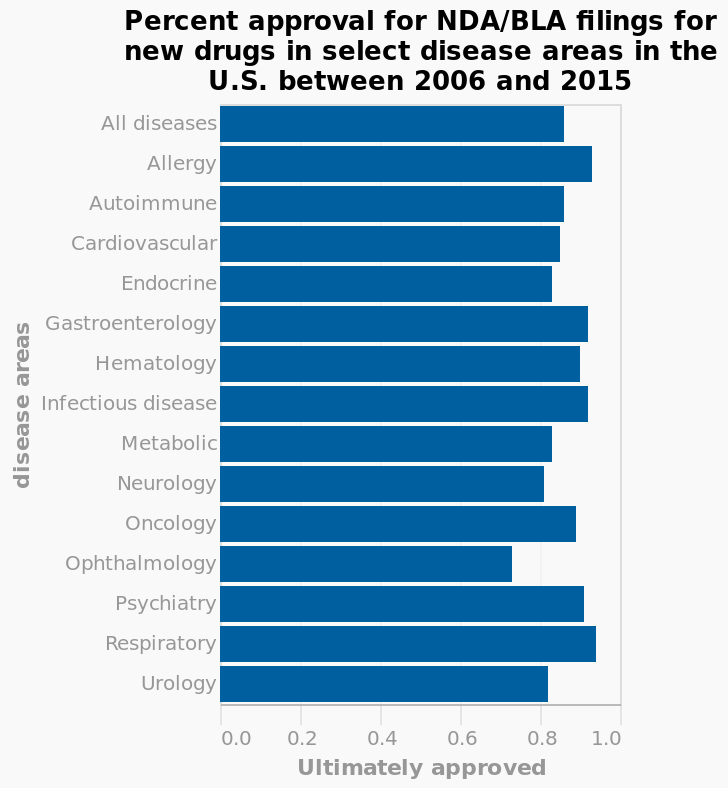<image>
please describe the details of the chart Here a is a bar plot called Percent approval for NDA/BLA filings for new drugs in select disease areas in the U.S. between 2006 and 2015. disease areas is drawn along the y-axis. On the x-axis, Ultimately approved is drawn with a linear scale with a minimum of 0.0 and a maximum of 1.0. What is represented on the x-axis of the bar plot? The "Ultimately approved" value is represented on the x-axis of the bar plot. 